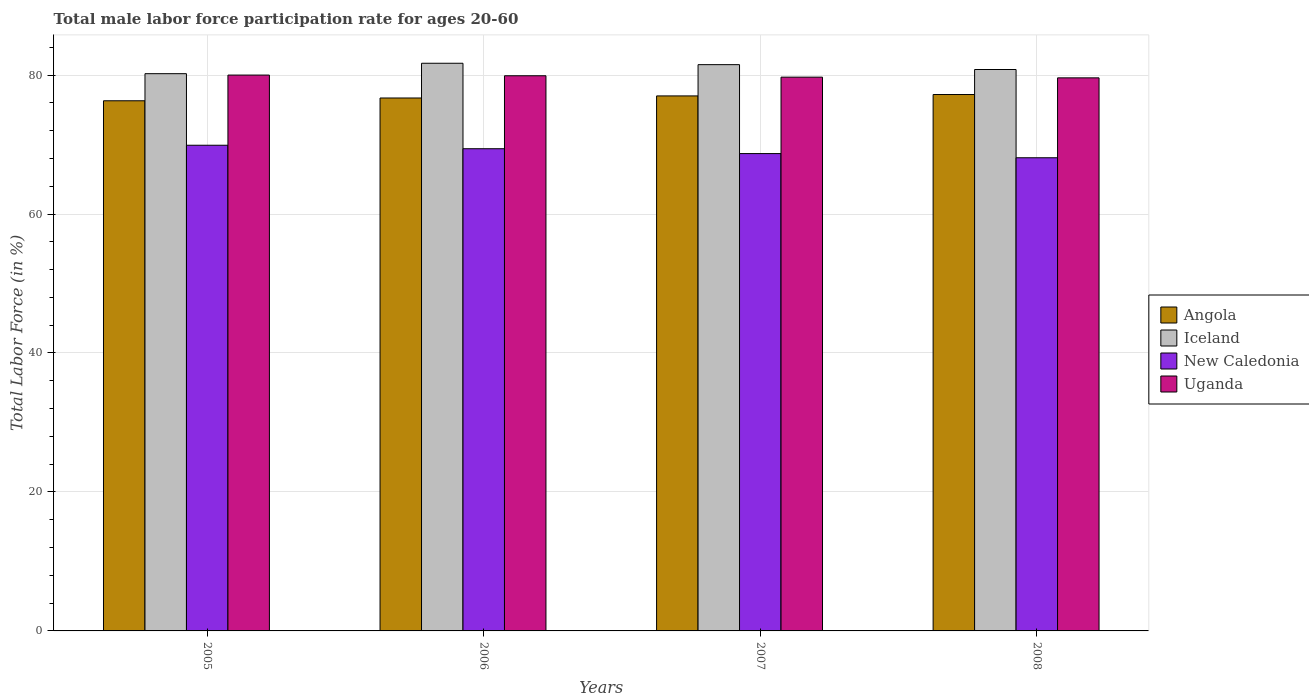How many different coloured bars are there?
Provide a succinct answer. 4. Are the number of bars on each tick of the X-axis equal?
Offer a terse response. Yes. In how many cases, is the number of bars for a given year not equal to the number of legend labels?
Ensure brevity in your answer.  0. What is the male labor force participation rate in New Caledonia in 2008?
Offer a terse response. 68.1. Across all years, what is the maximum male labor force participation rate in Iceland?
Provide a short and direct response. 81.7. Across all years, what is the minimum male labor force participation rate in Iceland?
Provide a short and direct response. 80.2. In which year was the male labor force participation rate in Iceland minimum?
Ensure brevity in your answer.  2005. What is the total male labor force participation rate in Iceland in the graph?
Your answer should be compact. 324.2. What is the difference between the male labor force participation rate in Angola in 2005 and that in 2007?
Offer a very short reply. -0.7. What is the difference between the male labor force participation rate in Iceland in 2007 and the male labor force participation rate in New Caledonia in 2005?
Keep it short and to the point. 11.6. What is the average male labor force participation rate in Angola per year?
Offer a terse response. 76.8. In the year 2005, what is the difference between the male labor force participation rate in Iceland and male labor force participation rate in New Caledonia?
Provide a short and direct response. 10.3. What is the ratio of the male labor force participation rate in Uganda in 2006 to that in 2008?
Your answer should be very brief. 1. Is the male labor force participation rate in Iceland in 2005 less than that in 2006?
Your answer should be compact. Yes. Is the difference between the male labor force participation rate in Iceland in 2005 and 2006 greater than the difference between the male labor force participation rate in New Caledonia in 2005 and 2006?
Make the answer very short. No. What is the difference between the highest and the second highest male labor force participation rate in Angola?
Your answer should be compact. 0.2. What is the difference between the highest and the lowest male labor force participation rate in Uganda?
Your answer should be very brief. 0.4. Is it the case that in every year, the sum of the male labor force participation rate in Uganda and male labor force participation rate in Iceland is greater than the sum of male labor force participation rate in Angola and male labor force participation rate in New Caledonia?
Make the answer very short. Yes. What does the 4th bar from the left in 2008 represents?
Your answer should be compact. Uganda. How many bars are there?
Your response must be concise. 16. Does the graph contain any zero values?
Keep it short and to the point. No. Does the graph contain grids?
Keep it short and to the point. Yes. What is the title of the graph?
Offer a very short reply. Total male labor force participation rate for ages 20-60. Does "Papua New Guinea" appear as one of the legend labels in the graph?
Your answer should be compact. No. What is the label or title of the Y-axis?
Ensure brevity in your answer.  Total Labor Force (in %). What is the Total Labor Force (in %) of Angola in 2005?
Offer a very short reply. 76.3. What is the Total Labor Force (in %) of Iceland in 2005?
Offer a terse response. 80.2. What is the Total Labor Force (in %) in New Caledonia in 2005?
Your answer should be compact. 69.9. What is the Total Labor Force (in %) of Angola in 2006?
Your answer should be very brief. 76.7. What is the Total Labor Force (in %) of Iceland in 2006?
Ensure brevity in your answer.  81.7. What is the Total Labor Force (in %) of New Caledonia in 2006?
Give a very brief answer. 69.4. What is the Total Labor Force (in %) in Uganda in 2006?
Provide a short and direct response. 79.9. What is the Total Labor Force (in %) in Iceland in 2007?
Keep it short and to the point. 81.5. What is the Total Labor Force (in %) in New Caledonia in 2007?
Your response must be concise. 68.7. What is the Total Labor Force (in %) of Uganda in 2007?
Give a very brief answer. 79.7. What is the Total Labor Force (in %) of Angola in 2008?
Provide a short and direct response. 77.2. What is the Total Labor Force (in %) of Iceland in 2008?
Your answer should be very brief. 80.8. What is the Total Labor Force (in %) of New Caledonia in 2008?
Give a very brief answer. 68.1. What is the Total Labor Force (in %) in Uganda in 2008?
Your answer should be very brief. 79.6. Across all years, what is the maximum Total Labor Force (in %) of Angola?
Provide a succinct answer. 77.2. Across all years, what is the maximum Total Labor Force (in %) in Iceland?
Keep it short and to the point. 81.7. Across all years, what is the maximum Total Labor Force (in %) in New Caledonia?
Your response must be concise. 69.9. Across all years, what is the minimum Total Labor Force (in %) in Angola?
Ensure brevity in your answer.  76.3. Across all years, what is the minimum Total Labor Force (in %) in Iceland?
Provide a short and direct response. 80.2. Across all years, what is the minimum Total Labor Force (in %) in New Caledonia?
Your answer should be compact. 68.1. Across all years, what is the minimum Total Labor Force (in %) in Uganda?
Provide a short and direct response. 79.6. What is the total Total Labor Force (in %) of Angola in the graph?
Your answer should be compact. 307.2. What is the total Total Labor Force (in %) in Iceland in the graph?
Your answer should be very brief. 324.2. What is the total Total Labor Force (in %) in New Caledonia in the graph?
Provide a short and direct response. 276.1. What is the total Total Labor Force (in %) in Uganda in the graph?
Make the answer very short. 319.2. What is the difference between the Total Labor Force (in %) in New Caledonia in 2005 and that in 2006?
Offer a terse response. 0.5. What is the difference between the Total Labor Force (in %) in Angola in 2005 and that in 2007?
Offer a terse response. -0.7. What is the difference between the Total Labor Force (in %) of New Caledonia in 2005 and that in 2007?
Your answer should be very brief. 1.2. What is the difference between the Total Labor Force (in %) of Uganda in 2005 and that in 2007?
Your response must be concise. 0.3. What is the difference between the Total Labor Force (in %) of New Caledonia in 2006 and that in 2007?
Offer a terse response. 0.7. What is the difference between the Total Labor Force (in %) of Uganda in 2006 and that in 2007?
Your answer should be compact. 0.2. What is the difference between the Total Labor Force (in %) in New Caledonia in 2006 and that in 2008?
Keep it short and to the point. 1.3. What is the difference between the Total Labor Force (in %) of Uganda in 2006 and that in 2008?
Offer a very short reply. 0.3. What is the difference between the Total Labor Force (in %) in Iceland in 2007 and that in 2008?
Offer a terse response. 0.7. What is the difference between the Total Labor Force (in %) of Iceland in 2005 and the Total Labor Force (in %) of New Caledonia in 2006?
Offer a very short reply. 10.8. What is the difference between the Total Labor Force (in %) in Iceland in 2005 and the Total Labor Force (in %) in Uganda in 2006?
Offer a terse response. 0.3. What is the difference between the Total Labor Force (in %) of New Caledonia in 2005 and the Total Labor Force (in %) of Uganda in 2006?
Offer a terse response. -10. What is the difference between the Total Labor Force (in %) of Angola in 2005 and the Total Labor Force (in %) of Iceland in 2007?
Provide a succinct answer. -5.2. What is the difference between the Total Labor Force (in %) of Angola in 2005 and the Total Labor Force (in %) of New Caledonia in 2007?
Offer a terse response. 7.6. What is the difference between the Total Labor Force (in %) of Iceland in 2005 and the Total Labor Force (in %) of Uganda in 2007?
Offer a terse response. 0.5. What is the difference between the Total Labor Force (in %) in Angola in 2005 and the Total Labor Force (in %) in Uganda in 2008?
Your answer should be compact. -3.3. What is the difference between the Total Labor Force (in %) of Angola in 2006 and the Total Labor Force (in %) of Uganda in 2007?
Your response must be concise. -3. What is the difference between the Total Labor Force (in %) of Iceland in 2006 and the Total Labor Force (in %) of New Caledonia in 2007?
Your response must be concise. 13. What is the difference between the Total Labor Force (in %) of Iceland in 2006 and the Total Labor Force (in %) of Uganda in 2007?
Ensure brevity in your answer.  2. What is the difference between the Total Labor Force (in %) in New Caledonia in 2006 and the Total Labor Force (in %) in Uganda in 2007?
Provide a succinct answer. -10.3. What is the difference between the Total Labor Force (in %) in Angola in 2006 and the Total Labor Force (in %) in Iceland in 2008?
Your answer should be compact. -4.1. What is the difference between the Total Labor Force (in %) in Angola in 2006 and the Total Labor Force (in %) in Uganda in 2008?
Provide a succinct answer. -2.9. What is the difference between the Total Labor Force (in %) of Iceland in 2006 and the Total Labor Force (in %) of Uganda in 2008?
Provide a succinct answer. 2.1. What is the difference between the Total Labor Force (in %) in Angola in 2007 and the Total Labor Force (in %) in Iceland in 2008?
Offer a very short reply. -3.8. What is the difference between the Total Labor Force (in %) in Angola in 2007 and the Total Labor Force (in %) in New Caledonia in 2008?
Offer a very short reply. 8.9. What is the difference between the Total Labor Force (in %) in Angola in 2007 and the Total Labor Force (in %) in Uganda in 2008?
Your response must be concise. -2.6. What is the difference between the Total Labor Force (in %) of Iceland in 2007 and the Total Labor Force (in %) of Uganda in 2008?
Make the answer very short. 1.9. What is the difference between the Total Labor Force (in %) of New Caledonia in 2007 and the Total Labor Force (in %) of Uganda in 2008?
Your answer should be compact. -10.9. What is the average Total Labor Force (in %) of Angola per year?
Offer a terse response. 76.8. What is the average Total Labor Force (in %) in Iceland per year?
Provide a succinct answer. 81.05. What is the average Total Labor Force (in %) in New Caledonia per year?
Your answer should be very brief. 69.03. What is the average Total Labor Force (in %) in Uganda per year?
Ensure brevity in your answer.  79.8. In the year 2005, what is the difference between the Total Labor Force (in %) in Angola and Total Labor Force (in %) in Iceland?
Provide a succinct answer. -3.9. In the year 2005, what is the difference between the Total Labor Force (in %) in Iceland and Total Labor Force (in %) in New Caledonia?
Your answer should be very brief. 10.3. In the year 2005, what is the difference between the Total Labor Force (in %) in Iceland and Total Labor Force (in %) in Uganda?
Provide a succinct answer. 0.2. In the year 2005, what is the difference between the Total Labor Force (in %) of New Caledonia and Total Labor Force (in %) of Uganda?
Give a very brief answer. -10.1. In the year 2006, what is the difference between the Total Labor Force (in %) in Angola and Total Labor Force (in %) in Iceland?
Provide a short and direct response. -5. In the year 2006, what is the difference between the Total Labor Force (in %) of Angola and Total Labor Force (in %) of New Caledonia?
Give a very brief answer. 7.3. In the year 2006, what is the difference between the Total Labor Force (in %) in Angola and Total Labor Force (in %) in Uganda?
Your response must be concise. -3.2. In the year 2007, what is the difference between the Total Labor Force (in %) in Angola and Total Labor Force (in %) in Iceland?
Your response must be concise. -4.5. In the year 2007, what is the difference between the Total Labor Force (in %) of Angola and Total Labor Force (in %) of New Caledonia?
Your response must be concise. 8.3. In the year 2007, what is the difference between the Total Labor Force (in %) of Iceland and Total Labor Force (in %) of New Caledonia?
Make the answer very short. 12.8. In the year 2008, what is the difference between the Total Labor Force (in %) in Angola and Total Labor Force (in %) in Uganda?
Your answer should be compact. -2.4. In the year 2008, what is the difference between the Total Labor Force (in %) of New Caledonia and Total Labor Force (in %) of Uganda?
Make the answer very short. -11.5. What is the ratio of the Total Labor Force (in %) of Iceland in 2005 to that in 2006?
Offer a very short reply. 0.98. What is the ratio of the Total Labor Force (in %) of New Caledonia in 2005 to that in 2006?
Make the answer very short. 1.01. What is the ratio of the Total Labor Force (in %) in Angola in 2005 to that in 2007?
Make the answer very short. 0.99. What is the ratio of the Total Labor Force (in %) in New Caledonia in 2005 to that in 2007?
Offer a terse response. 1.02. What is the ratio of the Total Labor Force (in %) of Uganda in 2005 to that in 2007?
Your response must be concise. 1. What is the ratio of the Total Labor Force (in %) of Angola in 2005 to that in 2008?
Offer a very short reply. 0.99. What is the ratio of the Total Labor Force (in %) of New Caledonia in 2005 to that in 2008?
Ensure brevity in your answer.  1.03. What is the ratio of the Total Labor Force (in %) in Uganda in 2005 to that in 2008?
Offer a very short reply. 1. What is the ratio of the Total Labor Force (in %) in New Caledonia in 2006 to that in 2007?
Your answer should be compact. 1.01. What is the ratio of the Total Labor Force (in %) in Uganda in 2006 to that in 2007?
Offer a very short reply. 1. What is the ratio of the Total Labor Force (in %) in Angola in 2006 to that in 2008?
Keep it short and to the point. 0.99. What is the ratio of the Total Labor Force (in %) of Iceland in 2006 to that in 2008?
Ensure brevity in your answer.  1.01. What is the ratio of the Total Labor Force (in %) of New Caledonia in 2006 to that in 2008?
Your response must be concise. 1.02. What is the ratio of the Total Labor Force (in %) in Angola in 2007 to that in 2008?
Make the answer very short. 1. What is the ratio of the Total Labor Force (in %) in Iceland in 2007 to that in 2008?
Give a very brief answer. 1.01. What is the ratio of the Total Labor Force (in %) in New Caledonia in 2007 to that in 2008?
Make the answer very short. 1.01. What is the difference between the highest and the second highest Total Labor Force (in %) in New Caledonia?
Provide a short and direct response. 0.5. What is the difference between the highest and the lowest Total Labor Force (in %) in Iceland?
Give a very brief answer. 1.5. 